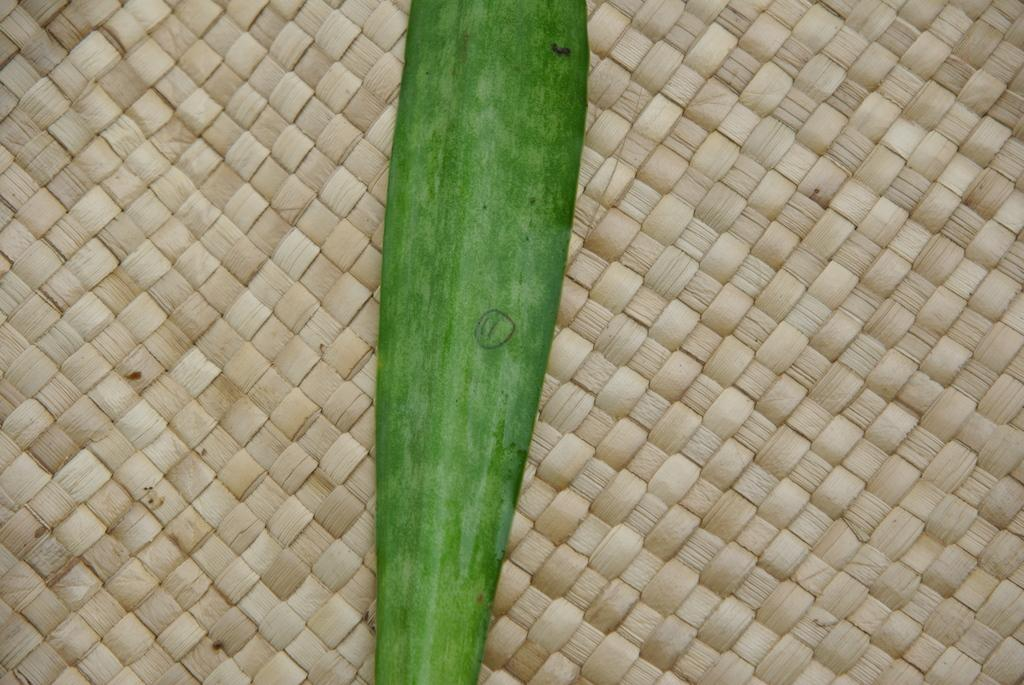What is present in the image? There is a leaf in the image. Can you describe the color of the leaf? The leaf is green in color. What material do the dried palm leaves appear to be made of? The leaf appears to be made of dried palm leaves. How many babies are present in the image? There are no babies present in the image; it only features a leaf. Which direction is the image facing? The image does not have a specific direction, as it is a still image of a leaf. 